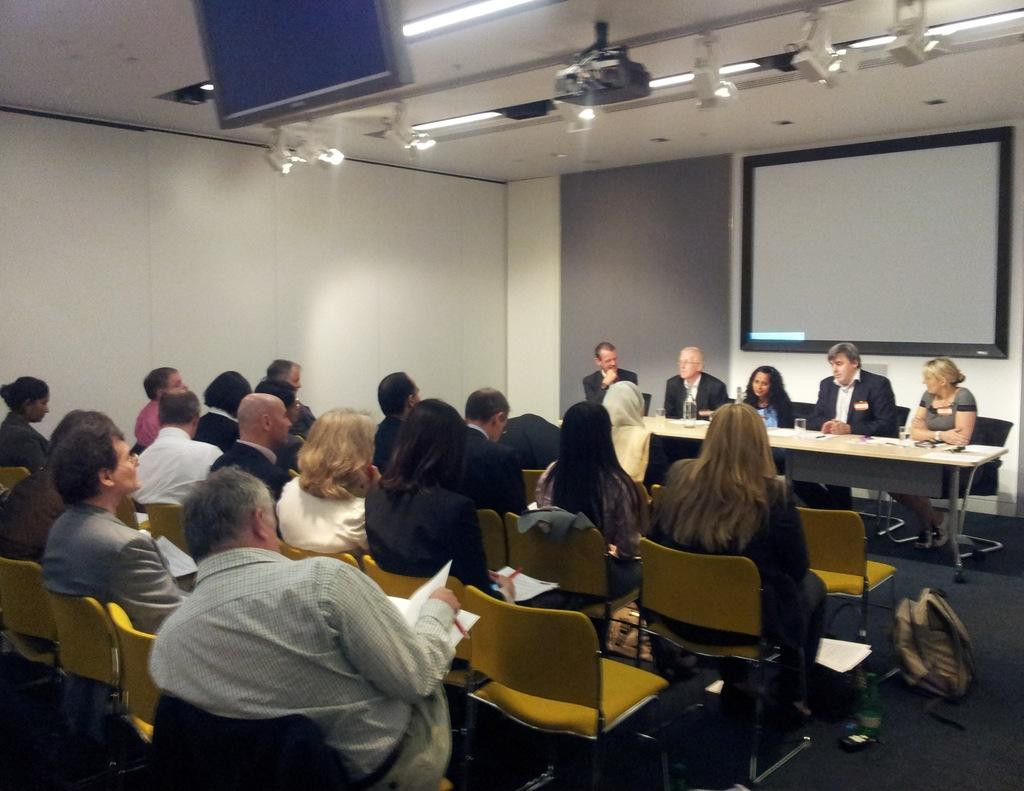Who is present in the image? There are people in the image. What are the people doing in the image? The people are sitting on chairs. What type of watch is the mother wearing in the image? There is no mention of a mother or a watch in the image, so it is not possible to answer that question. 